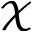<formula> <loc_0><loc_0><loc_500><loc_500>\mathcal { X }</formula> 